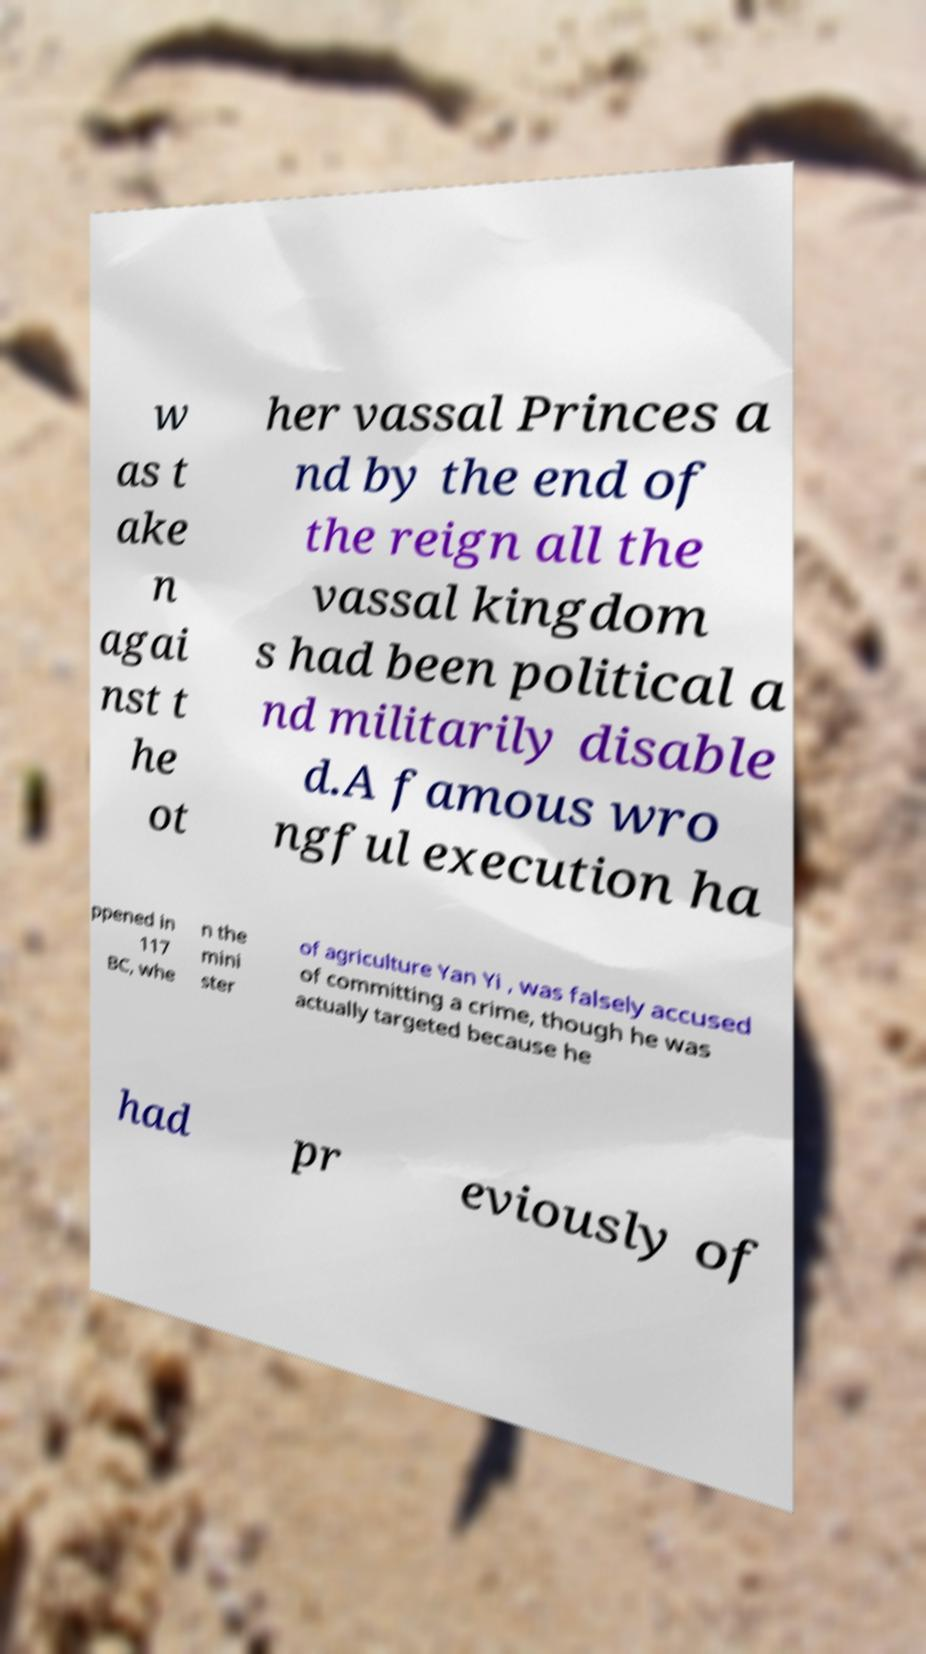Can you read and provide the text displayed in the image?This photo seems to have some interesting text. Can you extract and type it out for me? w as t ake n agai nst t he ot her vassal Princes a nd by the end of the reign all the vassal kingdom s had been political a nd militarily disable d.A famous wro ngful execution ha ppened in 117 BC, whe n the mini ster of agriculture Yan Yi , was falsely accused of committing a crime, though he was actually targeted because he had pr eviously of 